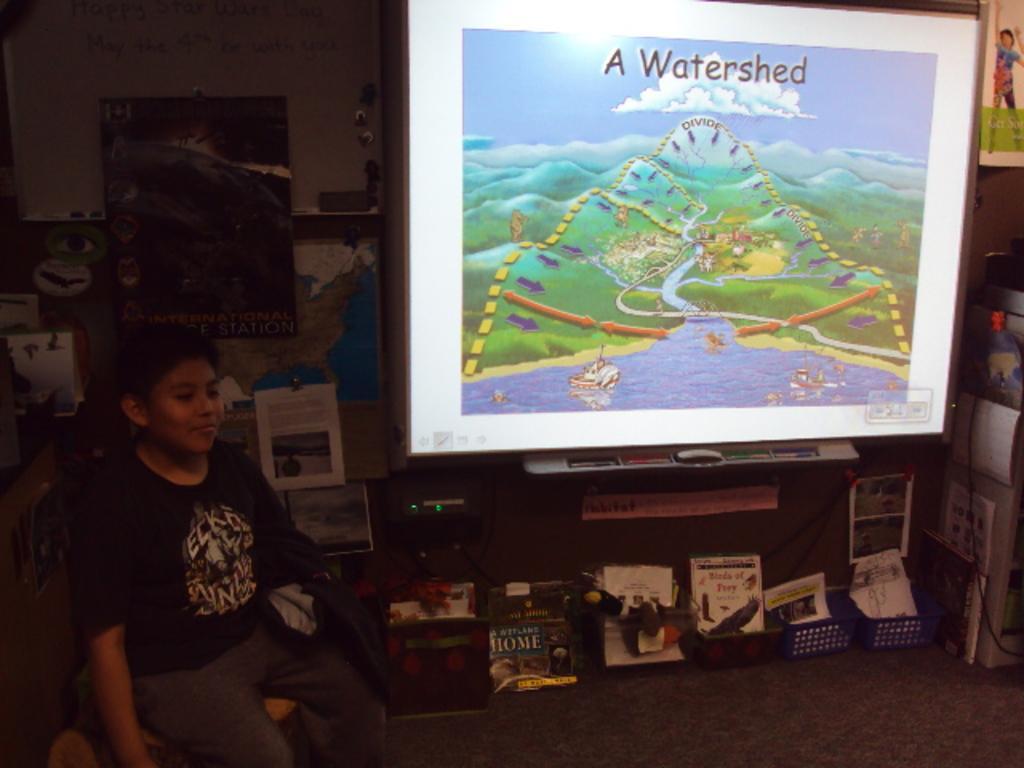In one or two sentences, can you explain what this image depicts? In this image the is a boy sitting on the chair , there are papers, toys and some objects in the trays, carpet, screen, pens, frames attached to the wall, map. 